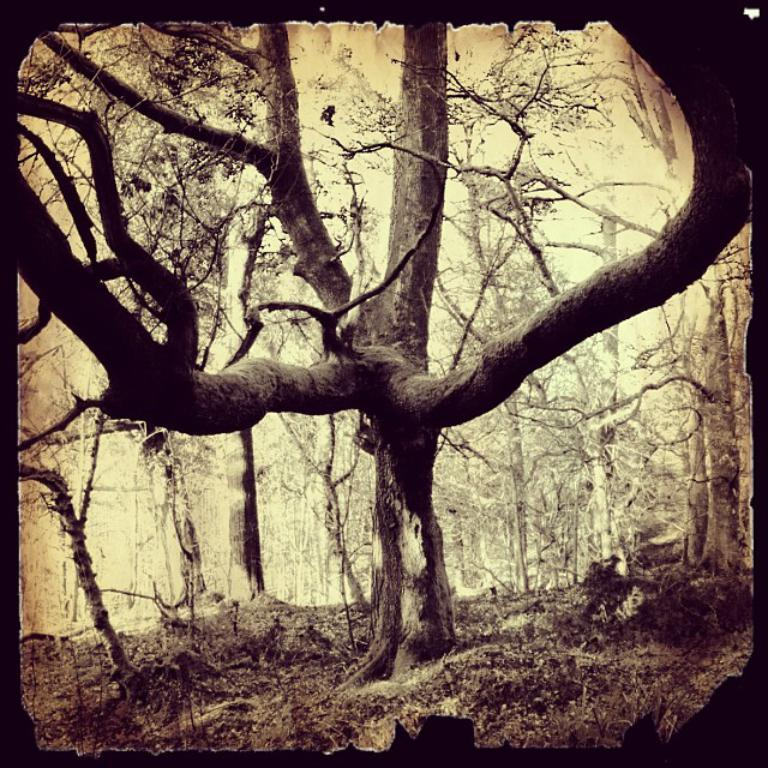What is the main subject of the image? There is a photograph in the image. What type of natural element can be seen in the image? There is a tree in the image. What type of ground is visible in the image? Soil is visible towards the bottom of the image. What color is the background of the image? The background of the image is white in color. How many beds are visible in the image? There are no beds present in the image. What type of wish can be granted by the tree in the image? The image does not depict a magical tree that can grant wishes. 